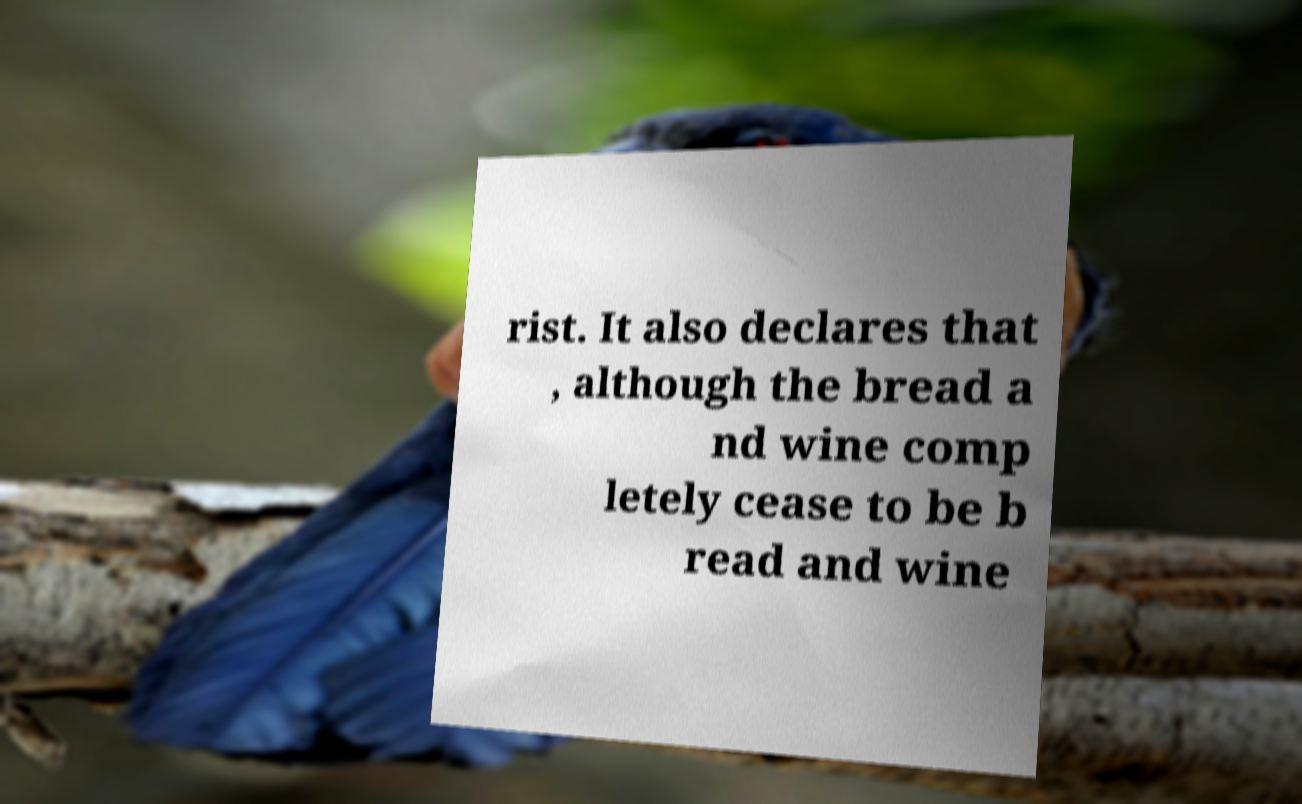Could you extract and type out the text from this image? rist. It also declares that , although the bread a nd wine comp letely cease to be b read and wine 